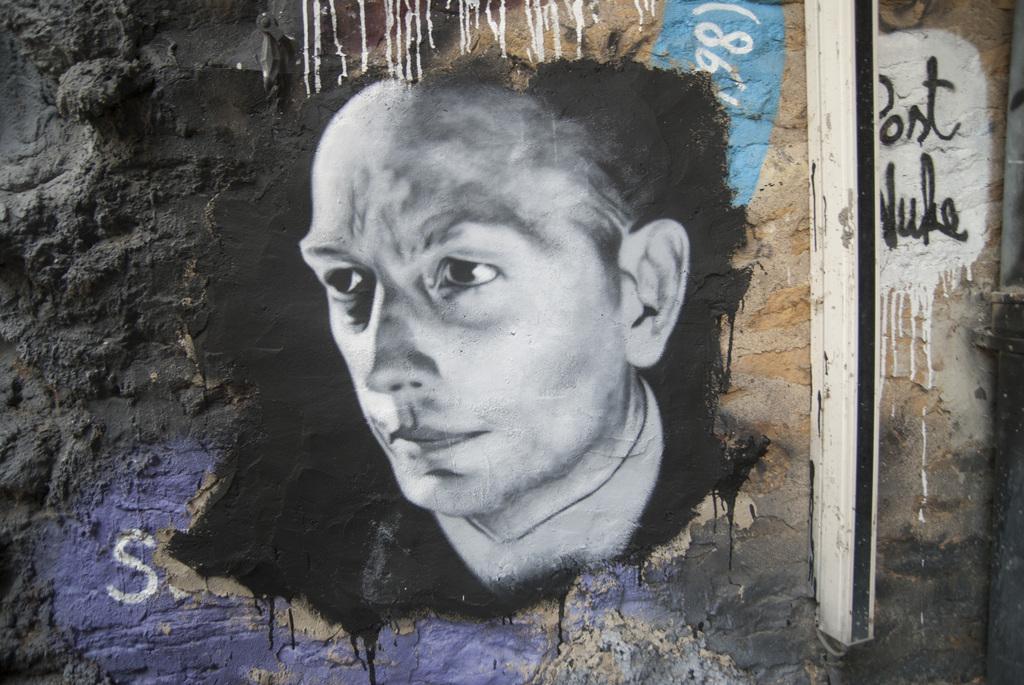Please provide a concise description of this image. In this picture we can see the painting of a person on the wall and on the wall it is written something and an object. 